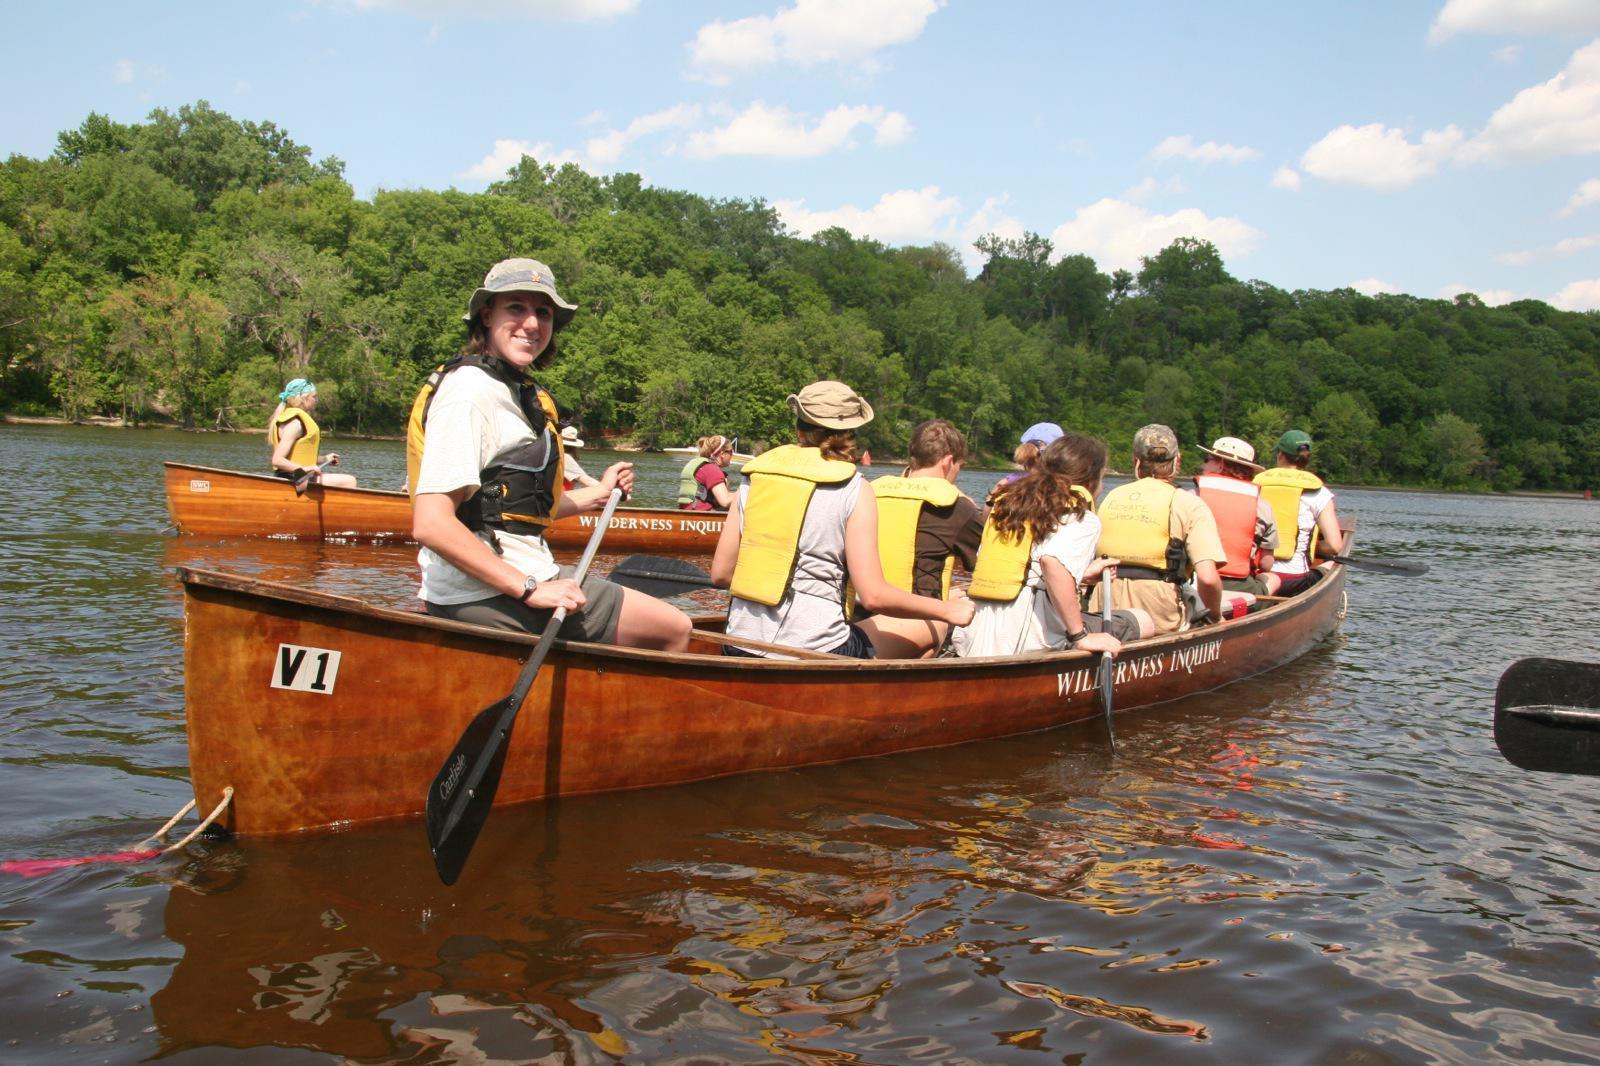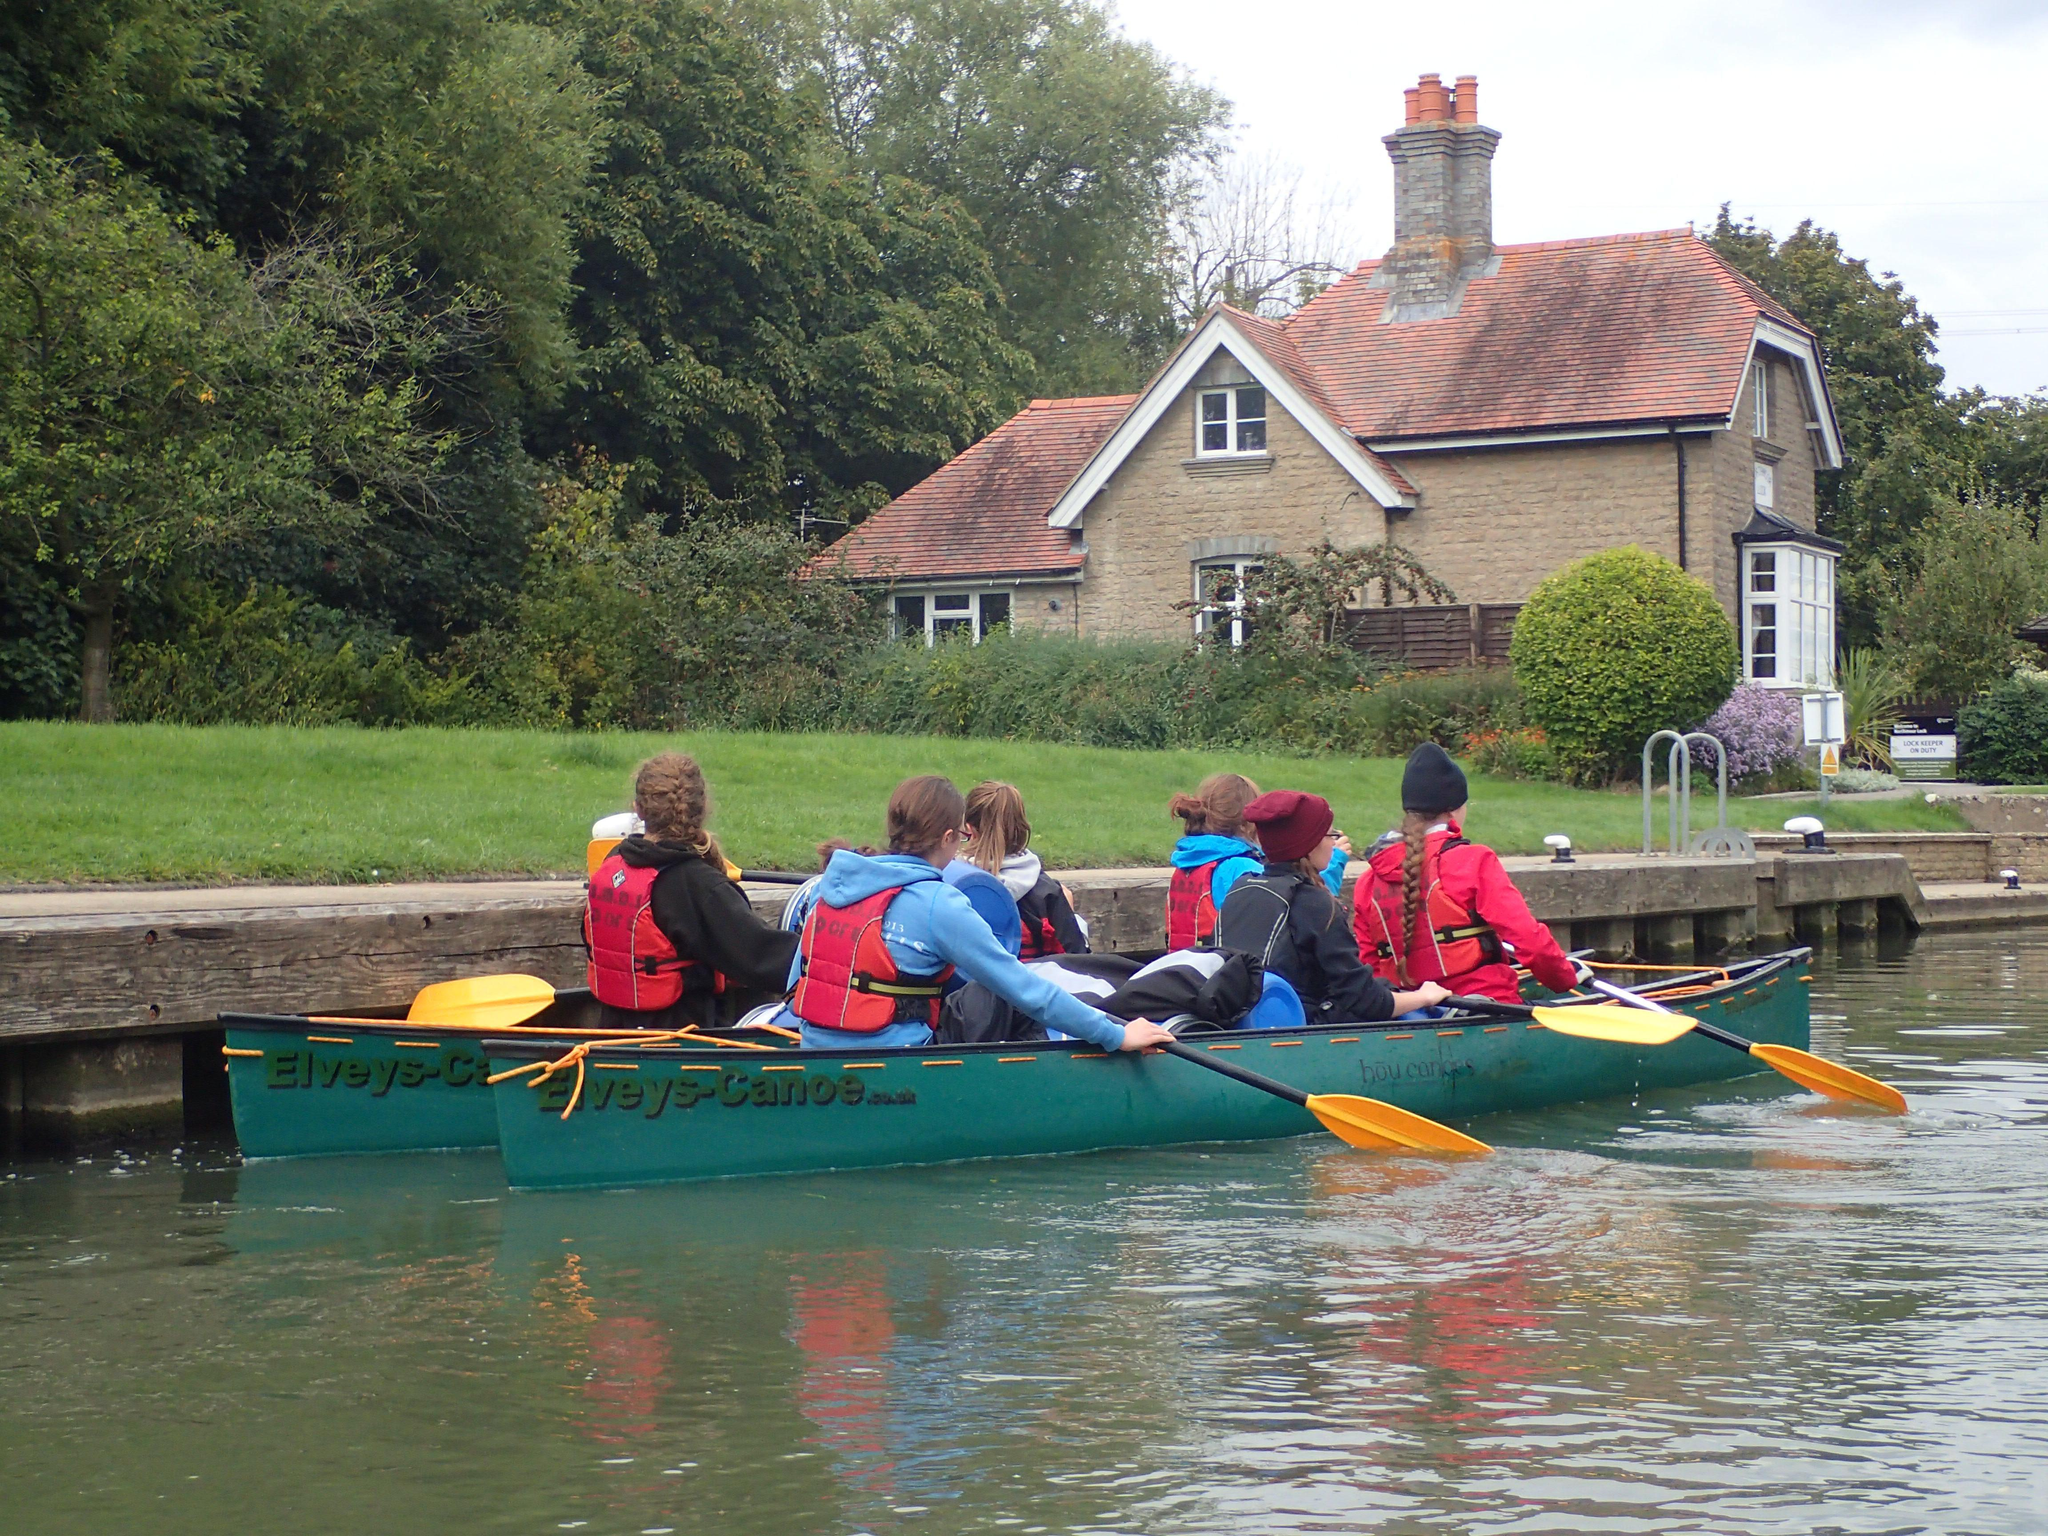The first image is the image on the left, the second image is the image on the right. For the images shown, is this caption "Three people ride a red canoe horizontally across the right image." true? Answer yes or no. No. The first image is the image on the left, the second image is the image on the right. For the images shown, is this caption "Three adults paddle a single canoe though the water in the image on the right." true? Answer yes or no. No. 